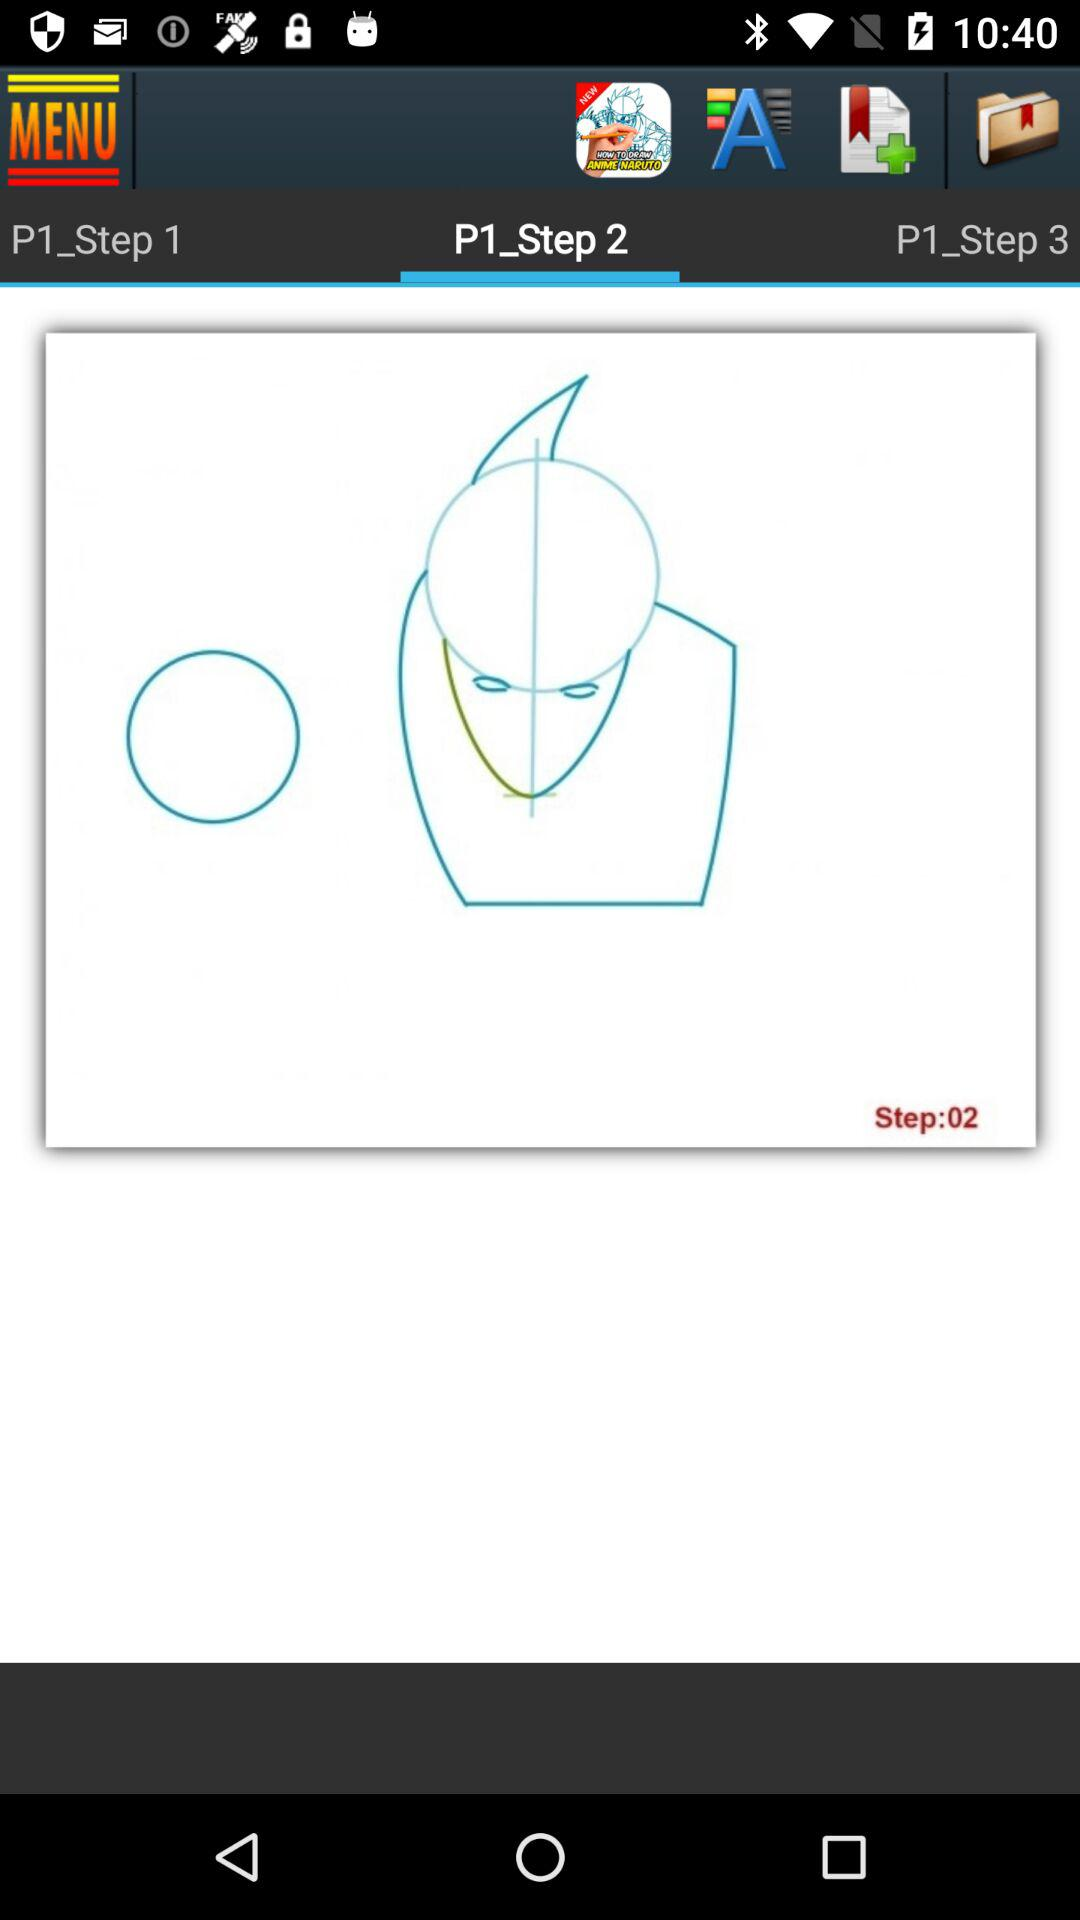How many steps are there in this tutorial?
Answer the question using a single word or phrase. 3 